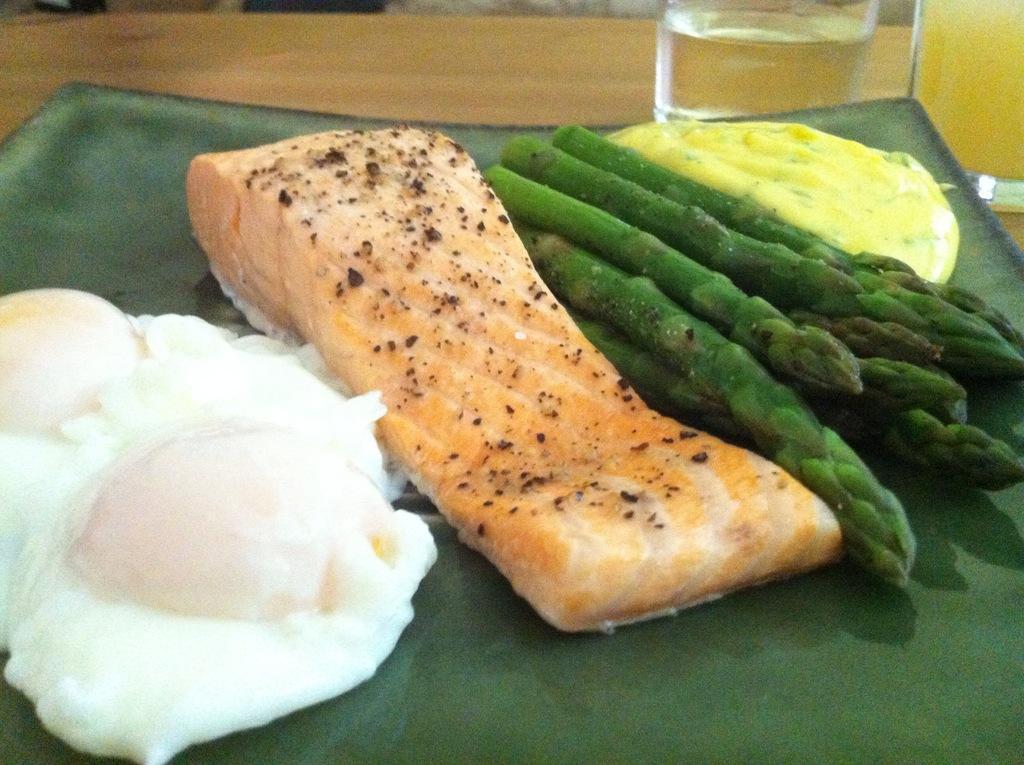Describe this image in one or two sentences. In this image, I can see asparagus, meat and few other food items in a plate, which is on a wooden object. In the top right corner of the image, I can see two glasses with liquids. 